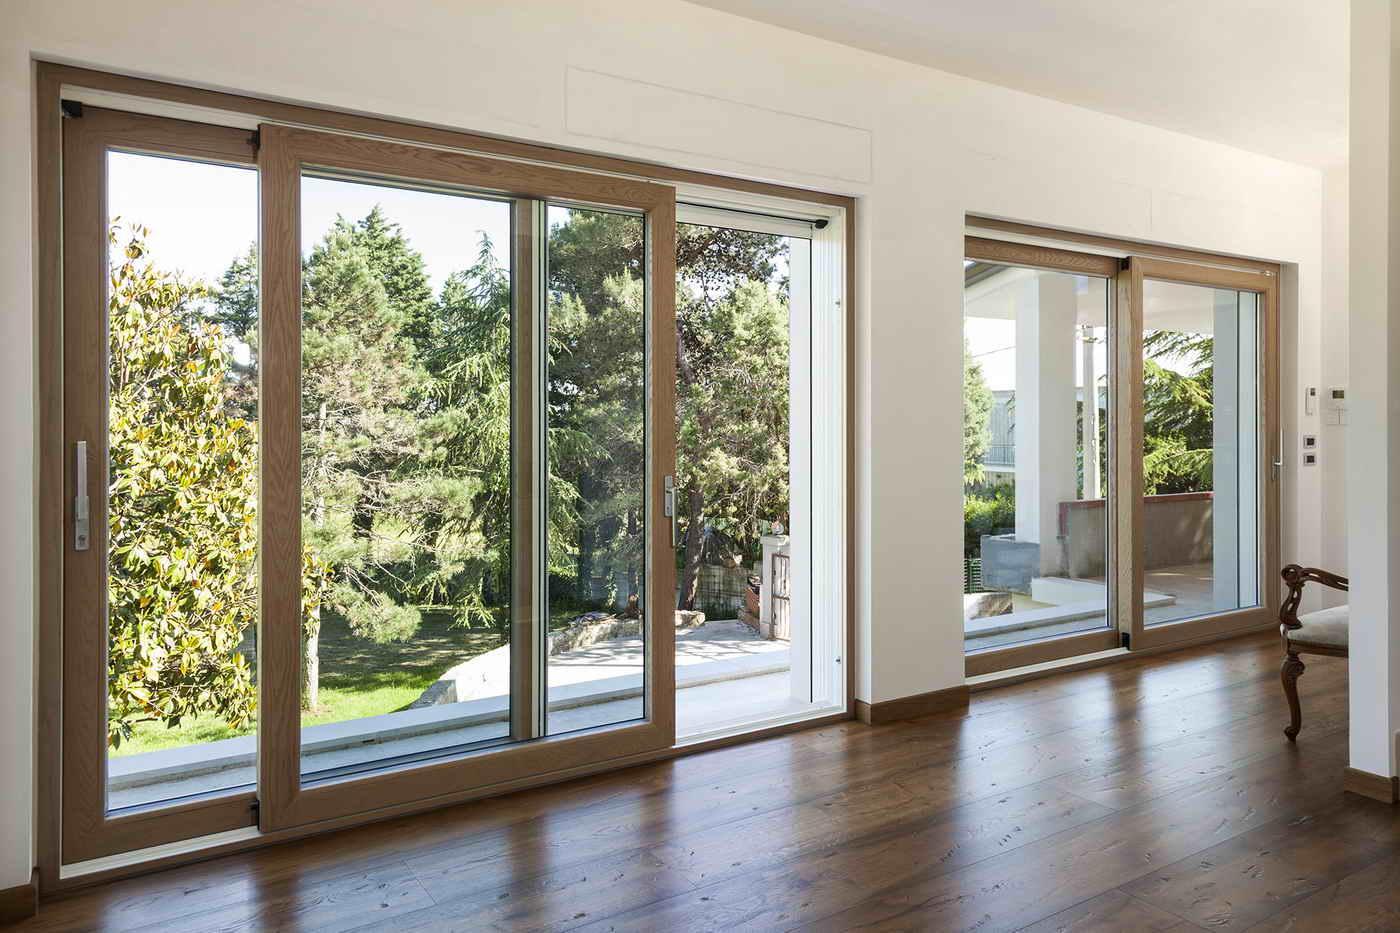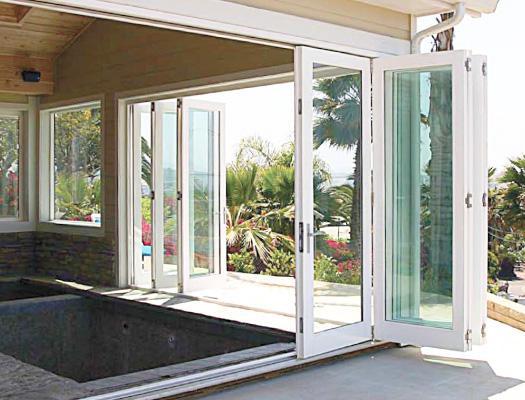The first image is the image on the left, the second image is the image on the right. For the images shown, is this caption "There are two glass door with multiple panes that reveal grass and foliage in the backyard." true? Answer yes or no. Yes. 